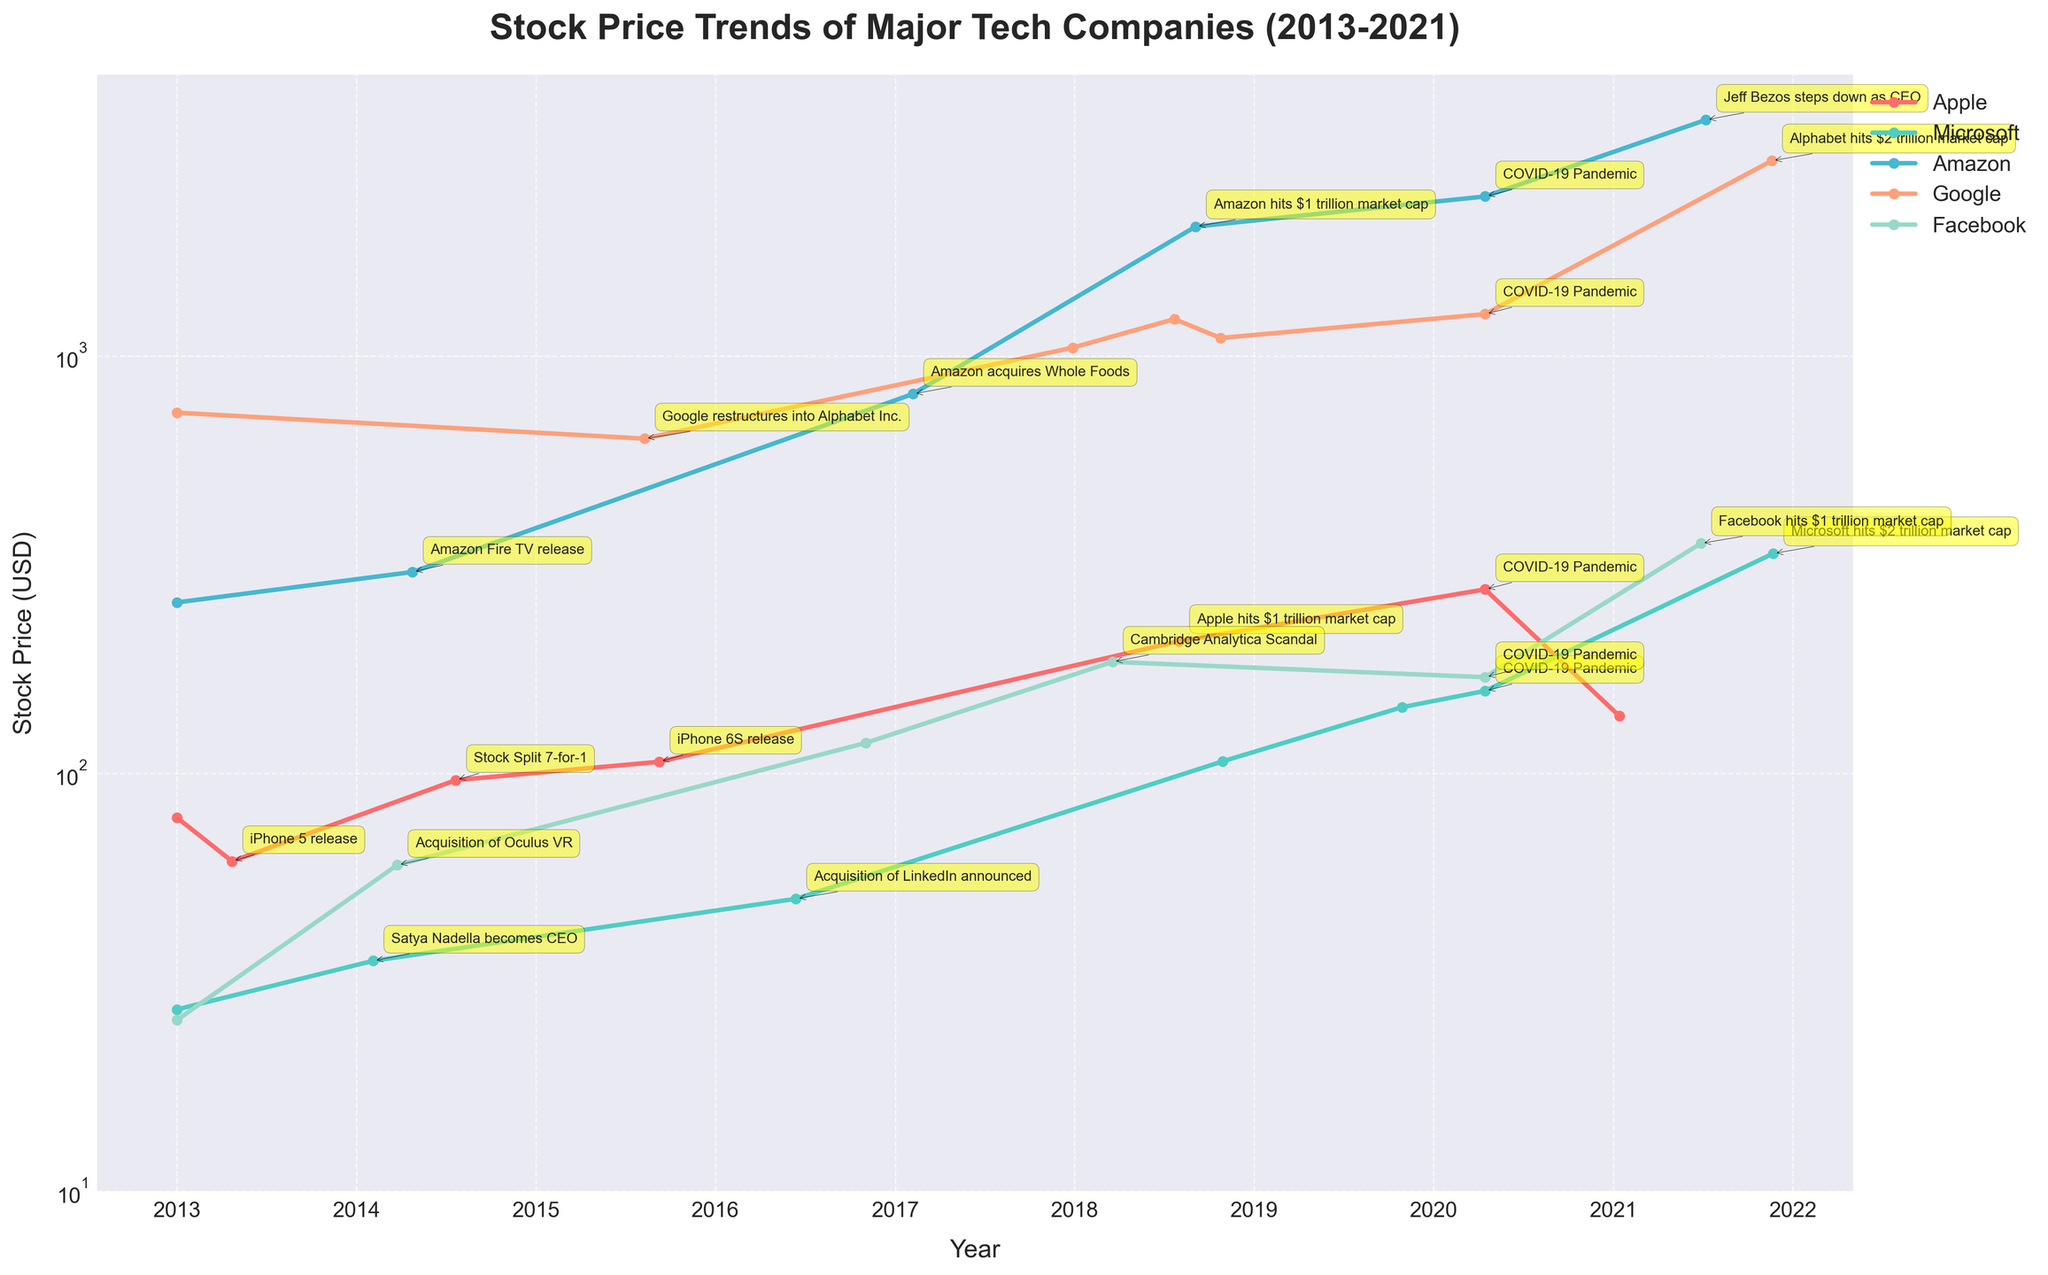What's the title of the plot? The title is displayed at the top of the plot and it gives an overview of what the data represents. In this case, it is "Stock Price Trends of Major Tech Companies (2013-2021)."
Answer: Stock Price Trends of Major Tech Companies (2013-2021) How many companies are shown in the plot? By looking at the legend, we can count the distinct company names listed and the different colored lines representing each. There are five companies: Apple, Microsoft, Amazon, Google, and Facebook.
Answer: 5 Identify the year Apple hit the $1 trillion market cap. On the Apple stock price line, there is a labeled event marking "Apple hits $1 trillion market cap." This event occurred in the year 2018.
Answer: 2018 What significant event happened to Facebook in 2018, and how did it affect their stock price? By examining the annotations on the Facebook stock price line around 2018, the event labeled is the "Cambridge Analytica Scandal." This event is associated with a dip in the stock price, showing a drop from previous values.
Answer: Cambridge Analytica Scandal, decreased Which company showed the highest stock price in 2021, and what was the price? First, check the endpoint of each company's stock price line on the plot for the year 2021. Alphabet (Google) shows the highest stock price in 2021 with a price point close to 2931.87 USD.
Answer: Alphabet (Google), 2931.87 USD Compare the stock prices of Amazon and Microsoft during the COVID-19 pandemic in April 2020. Which one had a higher price? Locate the stock prices for both Amazon and Microsoft on the date around April 2020. Amazon's stock price is labeled at approximately 2408.19 USD, whereas Microsoft's is labeled at 157.71 USD. Amazon had a higher stock price.
Answer: Amazon Calculate the difference between Microsoft's stock price when Satya Nadella became CEO and when the LinkedIn acquisition was announced. Satya Nadella became CEO in February 2014 and the stock price was 35.62 USD. The LinkedIn acquisition was announced in June 2016 with a stock price of 50.14 USD. The difference is 50.14 - 35.62 = 14.52 USD.
Answer: 14.52 USD Which company's stock price increased the most from 2013 to 2021? To determine the company with the most increase, compare the initial and final stock prices of each company from 2013 to 2021. Amazon's stock price went from 256.93 USD in 2013 to 3673.21 USD in 2021.
Answer: Amazon What trend can be observed in the stock prices of the major tech companies during the COVID-19 pandemic in April 2020? Observing the annotations around April 2020, there was a noticeable impact on the stock prices due to the COVID-19 pandemic. Despite initial volatility, most companies showed resilience with Amazon and Microsoft marking significant price points.
Answer: Most showed resilience, with significant points for Amazon & Microsoft Which company hit the $2 trillion market cap first, Microsoft or Google (Alphabet)? By looking at the respective annotations on the Microsoft and Alphabet stock price lines, Microsoft hit the $2 trillion market cap in November 2021, whereas Alphabet did the same in November 2021. Comparing the exact dates, Microsoft reached this milestone first.
Answer: Microsoft 